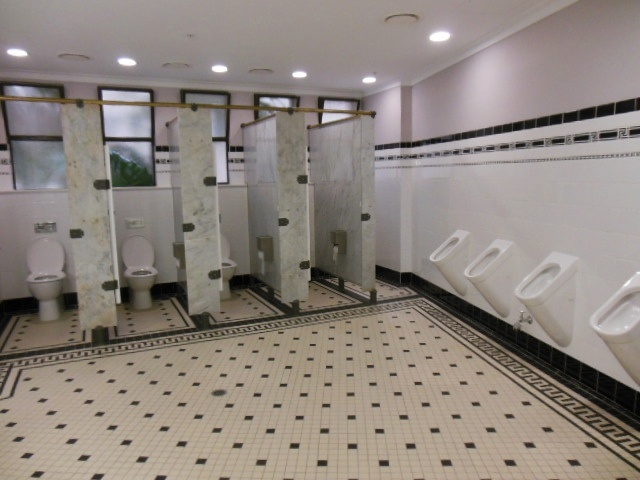Describe the objects in this image and their specific colors. I can see toilet in gray, darkgray, and lightgray tones, toilet in gray and darkgray tones, toilet in gray and black tones, toilet in gray and black tones, and toilet in gray and darkgray tones in this image. 